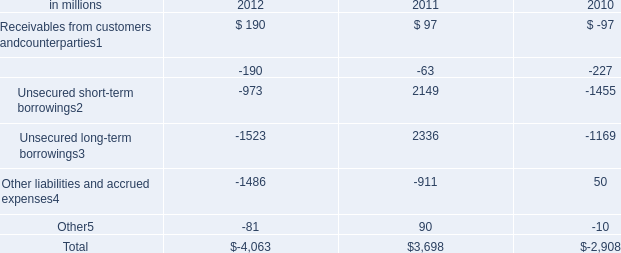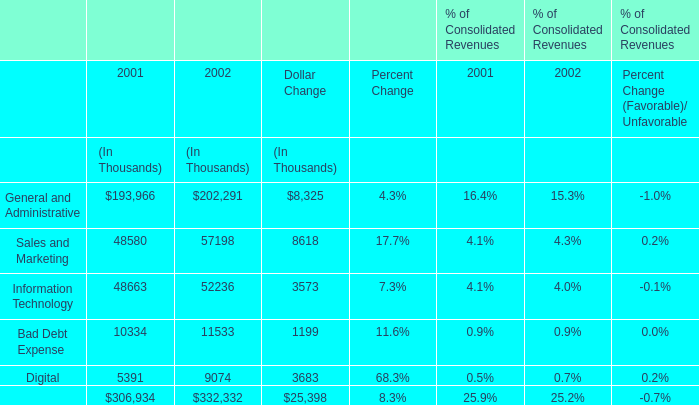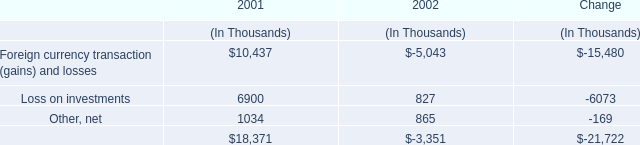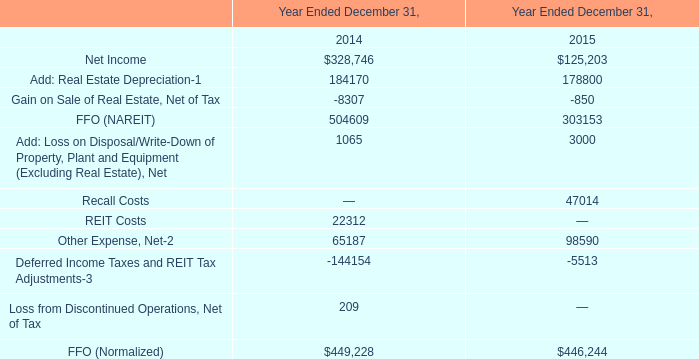Which year does the Bad Debt Expense rank higher? 
Answer: 2002. 